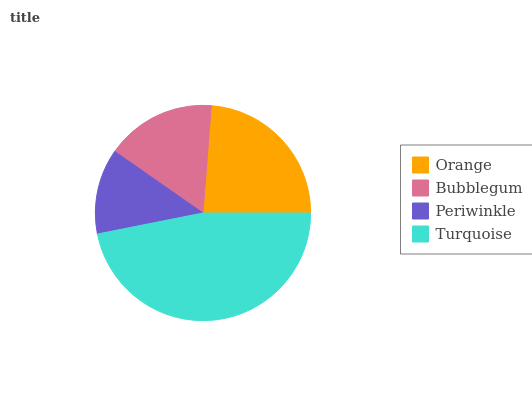Is Periwinkle the minimum?
Answer yes or no. Yes. Is Turquoise the maximum?
Answer yes or no. Yes. Is Bubblegum the minimum?
Answer yes or no. No. Is Bubblegum the maximum?
Answer yes or no. No. Is Orange greater than Bubblegum?
Answer yes or no. Yes. Is Bubblegum less than Orange?
Answer yes or no. Yes. Is Bubblegum greater than Orange?
Answer yes or no. No. Is Orange less than Bubblegum?
Answer yes or no. No. Is Orange the high median?
Answer yes or no. Yes. Is Bubblegum the low median?
Answer yes or no. Yes. Is Bubblegum the high median?
Answer yes or no. No. Is Periwinkle the low median?
Answer yes or no. No. 